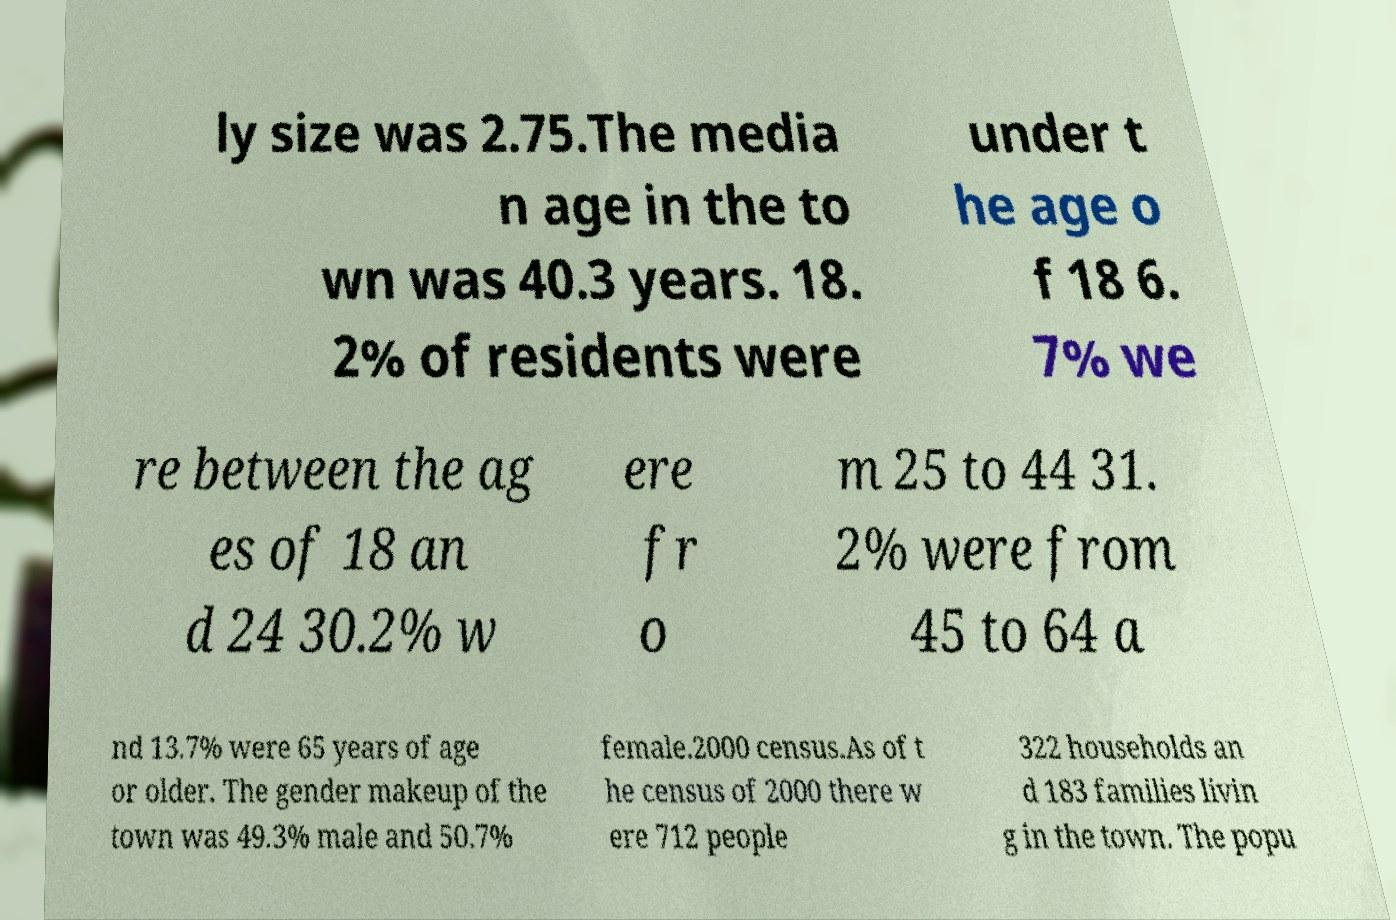Could you extract and type out the text from this image? ly size was 2.75.The media n age in the to wn was 40.3 years. 18. 2% of residents were under t he age o f 18 6. 7% we re between the ag es of 18 an d 24 30.2% w ere fr o m 25 to 44 31. 2% were from 45 to 64 a nd 13.7% were 65 years of age or older. The gender makeup of the town was 49.3% male and 50.7% female.2000 census.As of t he census of 2000 there w ere 712 people 322 households an d 183 families livin g in the town. The popu 